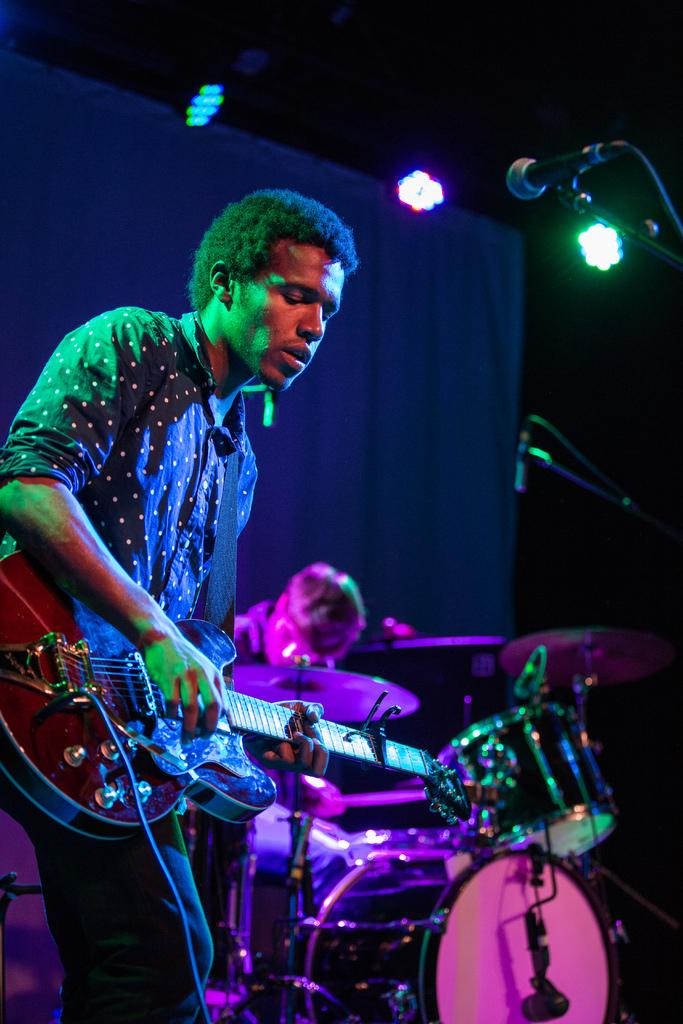What objects in the image are related to sound production? In the image, there is a microphone (mic) and musical drums, both of which are related to sound production. What musical instrument can be seen in the image? There is a guitar in the image. How many people are present in the image? There are two persons in the image. What type of lighting is present in the image? There are lights in the image. Can you see a coil or a crown in the image? No, there is no coil or crown present in the image. What type of bulb is used for the lighting in the image? The provided facts do not mention the type of bulb used for the lighting in the image. 